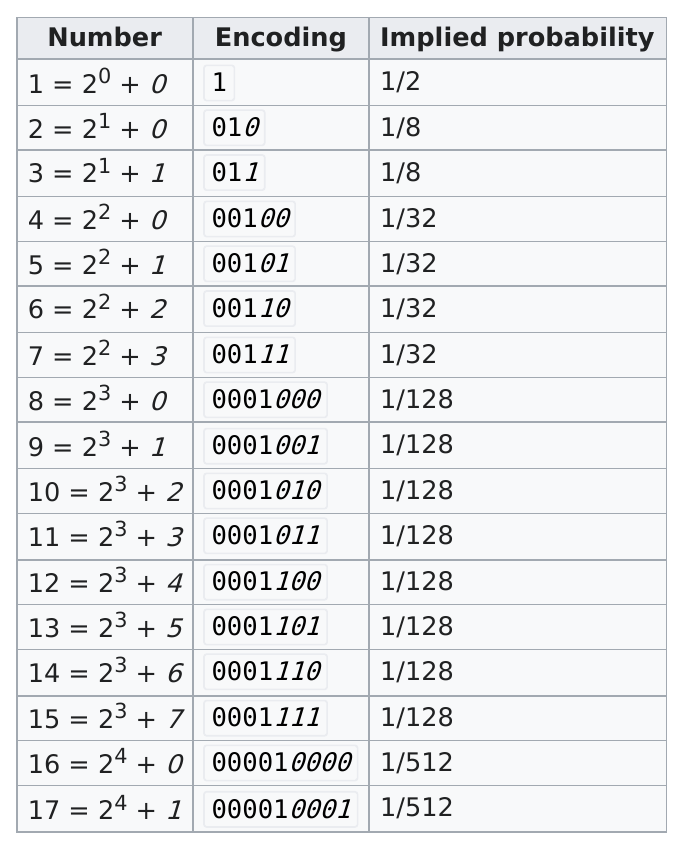Draw attention to some important aspects in this diagram. The Elias Gamma encoding uses a specific set of binary codes to represent the first five integers. These codes are 1, 010, 011, 00100, and 00101. The implied probability of 8 being equal to 23 plus zero is one in one hundred twenty-eight. The first five implied probabilities in Elias Gamma coding are 0.5, 0.125, 0.125, 0.03125, and 0.03125, respectively. 